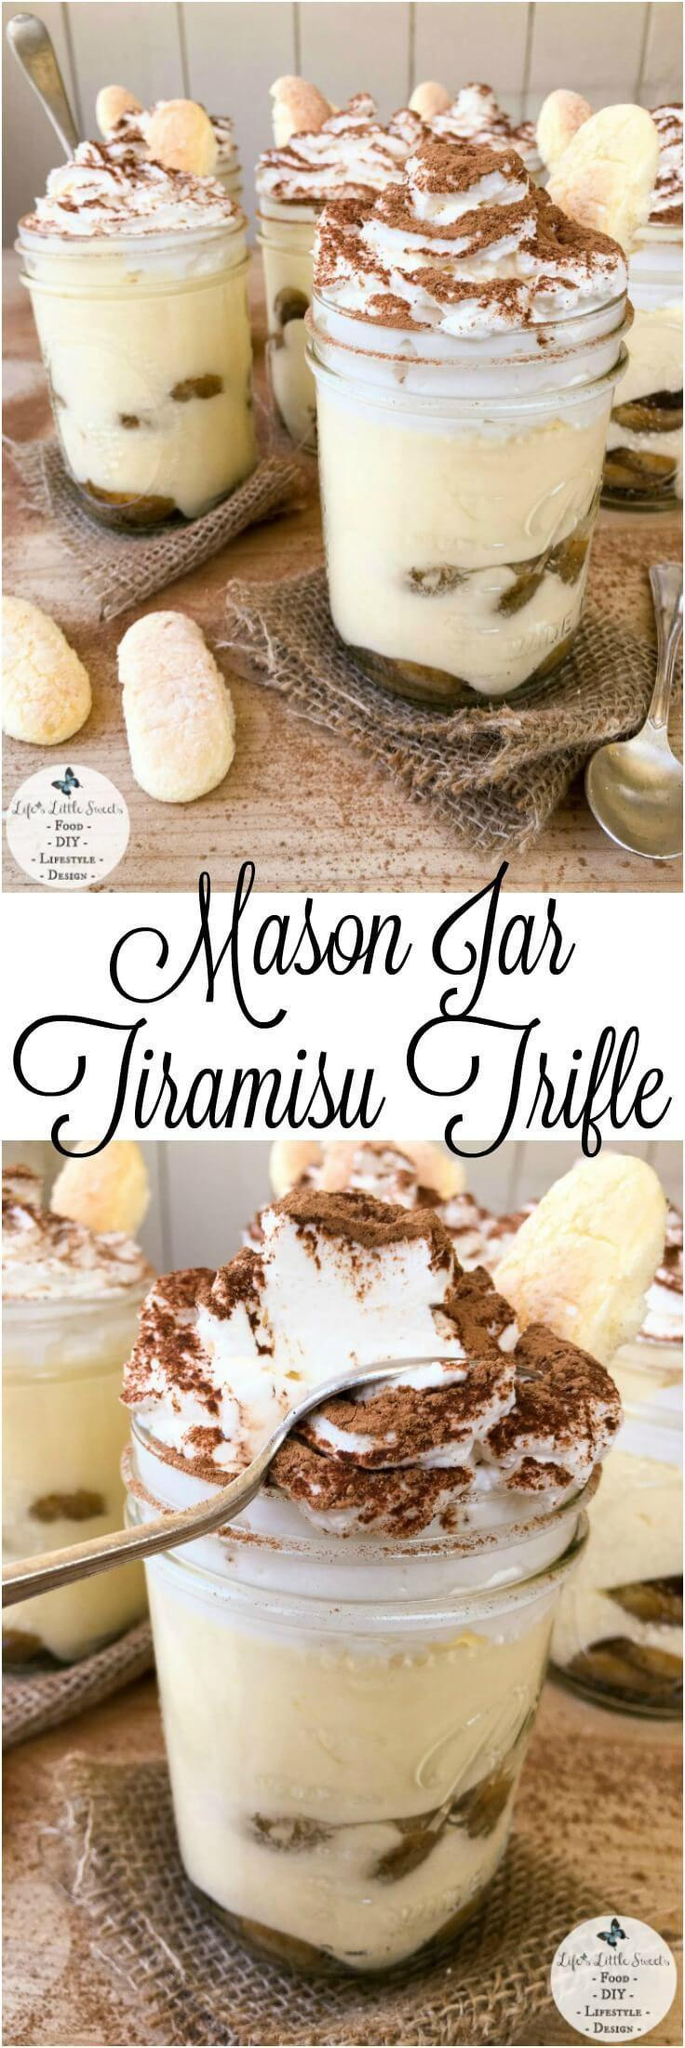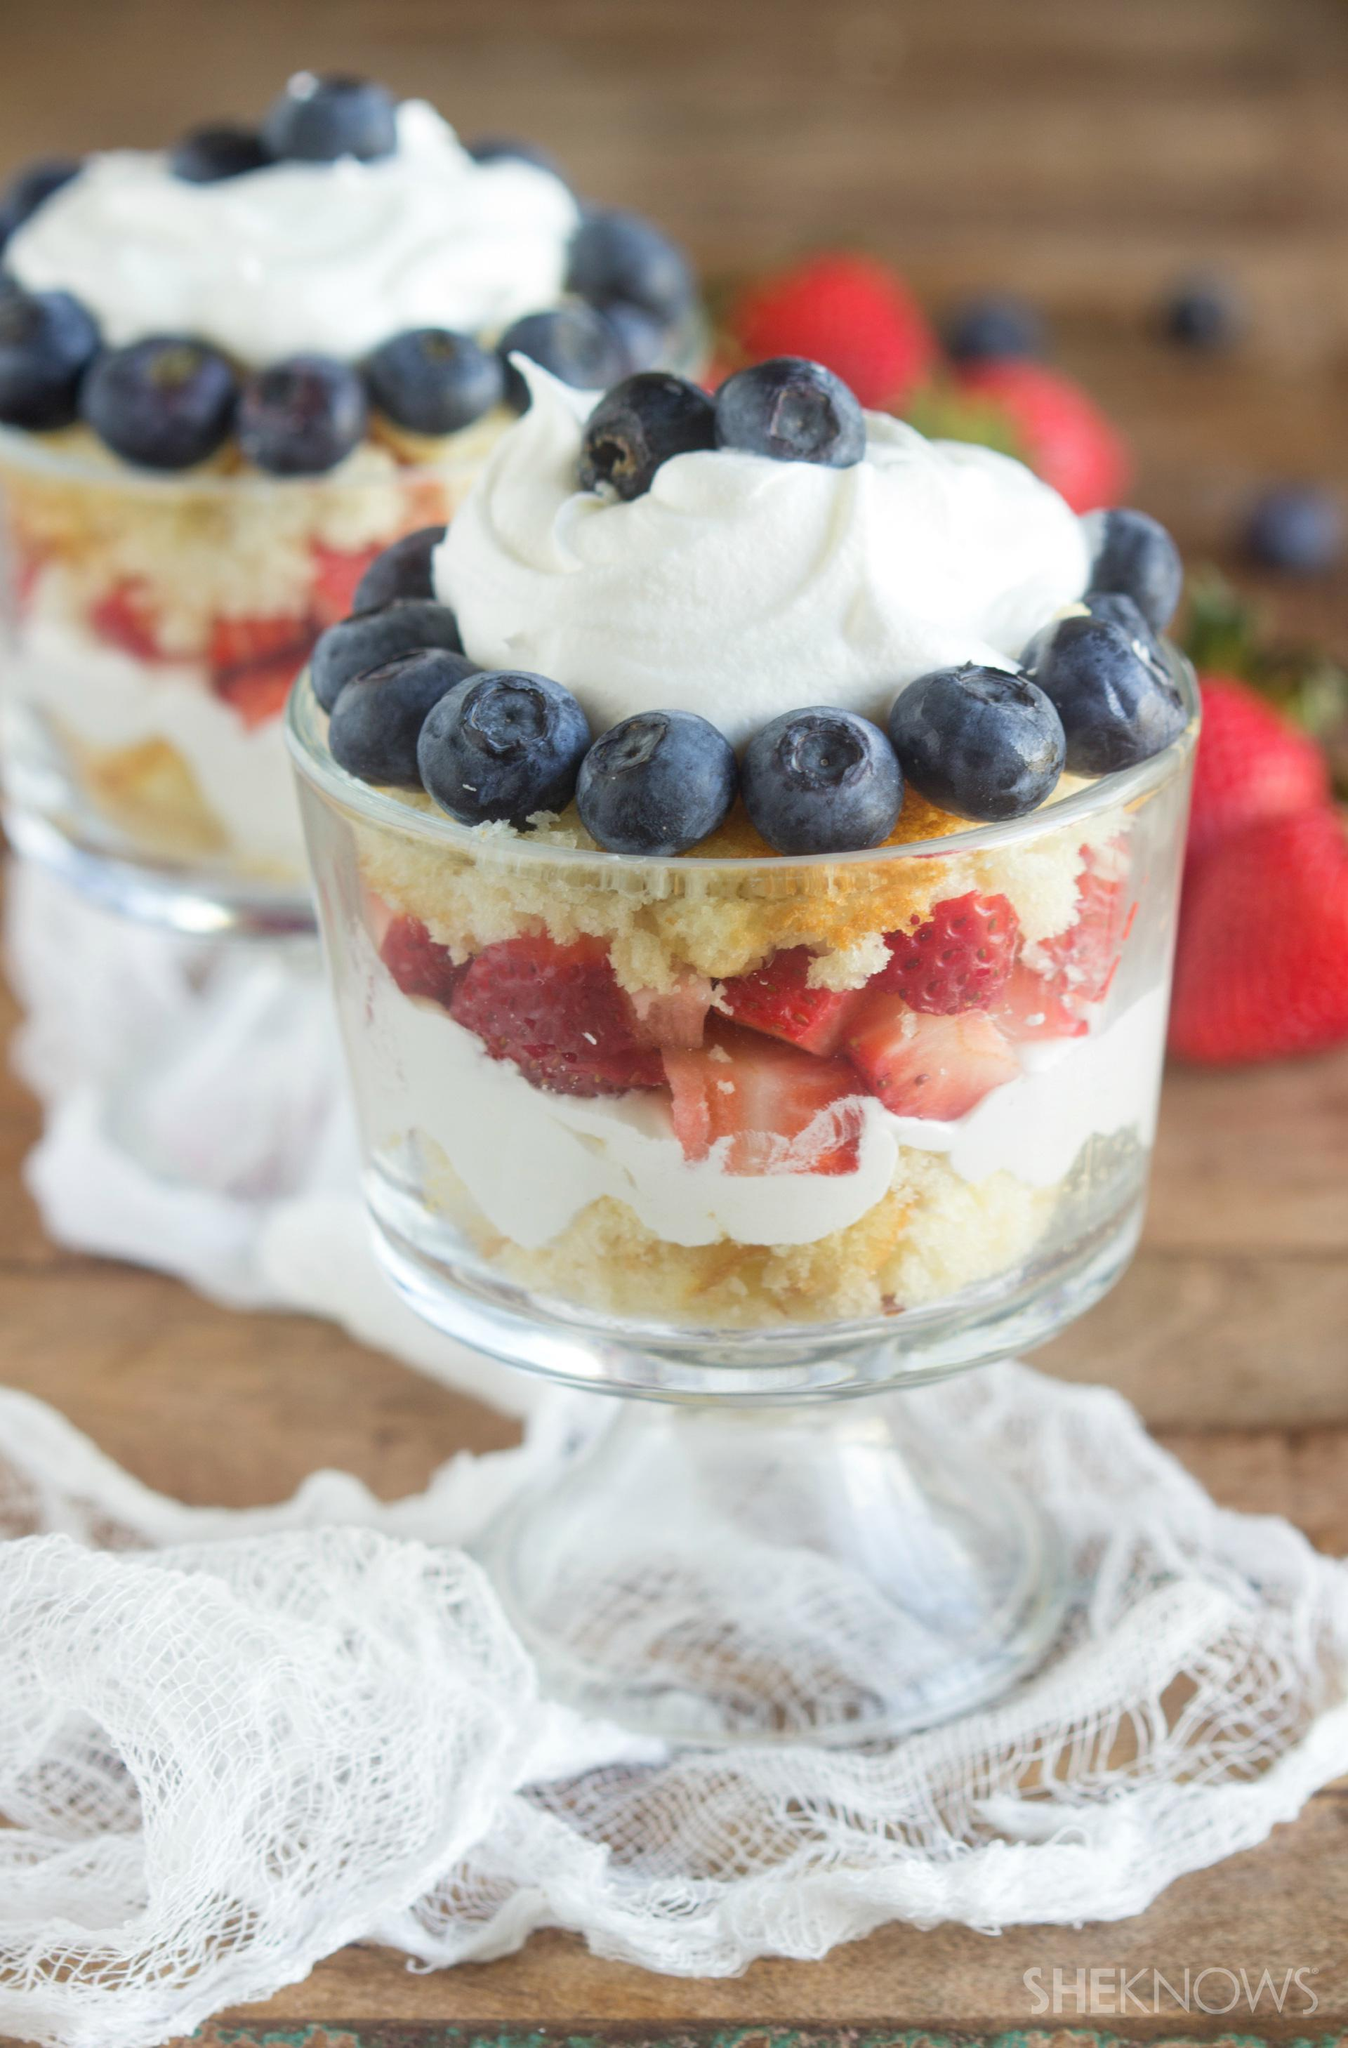The first image is the image on the left, the second image is the image on the right. Analyze the images presented: Is the assertion "One image shows a large layered dessert in a clear footed bowl, topped with a thick creamy layer and a garnish of the same items used in a lower layer." valid? Answer yes or no. No. The first image is the image on the left, the second image is the image on the right. Given the left and right images, does the statement "A dessert in a footed glass has a neat row of berries around the rim for garnish." hold true? Answer yes or no. Yes. 